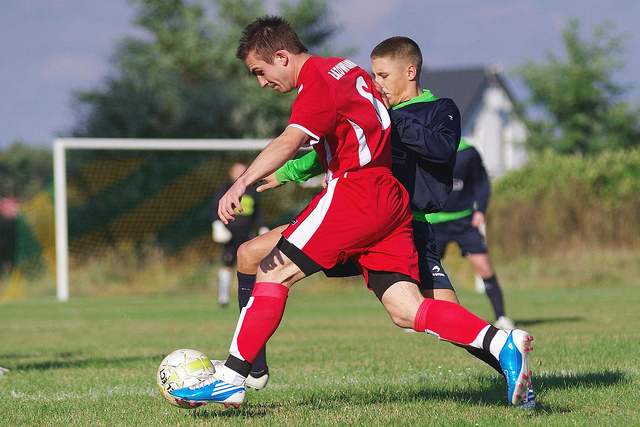<image>Why are there only two men going after the ball? It is ambiguous why there are only two men going after the ball. Why are there only two men going after the ball? I don't know why there are only two men going after the ball. It could be because they are waiting their turn, or they are near the ball. 